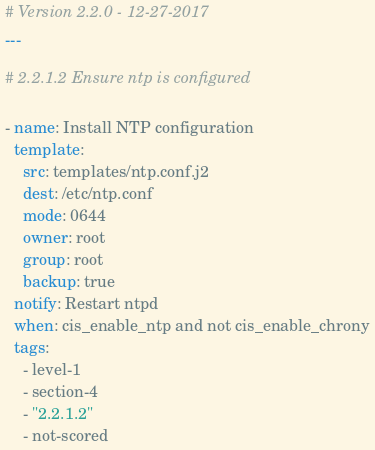<code> <loc_0><loc_0><loc_500><loc_500><_YAML_># Version 2.2.0 - 12-27-2017
---

# 2.2.1.2 Ensure ntp is configured

- name: Install NTP configuration
  template:
    src: templates/ntp.conf.j2
    dest: /etc/ntp.conf
    mode: 0644
    owner: root
    group: root
    backup: true
  notify: Restart ntpd
  when: cis_enable_ntp and not cis_enable_chrony
  tags:
    - level-1
    - section-4
    - "2.2.1.2"
    - not-scored
</code> 